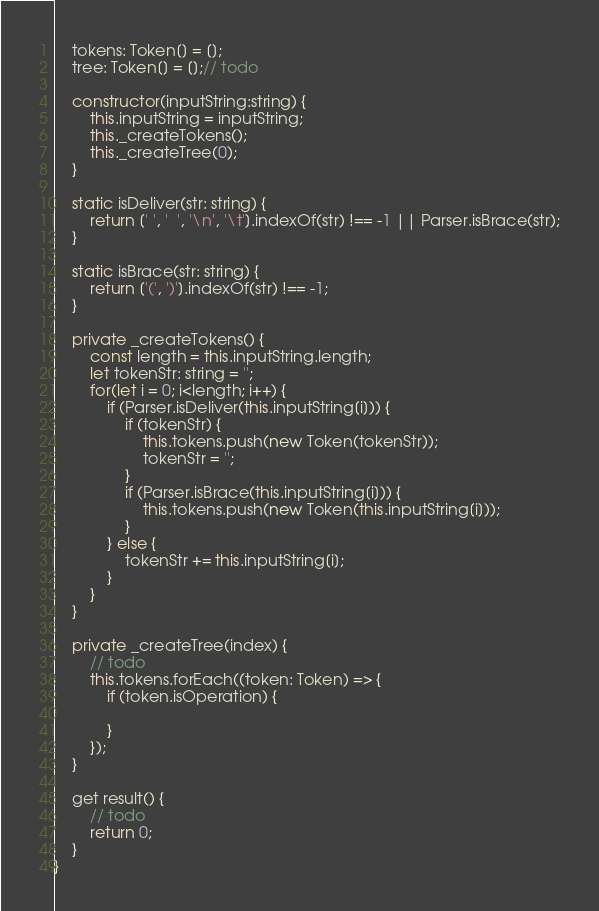<code> <loc_0><loc_0><loc_500><loc_500><_TypeScript_>    tokens: Token[] = [];
    tree: Token[] = [];// todo
    
    constructor(inputString:string) {
        this.inputString = inputString;
        this._createTokens();
        this._createTree(0);
    }

    static isDeliver(str: string) {
        return [' ', '  ', '\n', '\t'].indexOf(str) !== -1 || Parser.isBrace(str);
    }

    static isBrace(str: string) {
        return ['(', ')'].indexOf(str) !== -1;
    }

    private _createTokens() {
        const length = this.inputString.length;
        let tokenStr: string = '';
        for(let i = 0; i<length; i++) {
            if (Parser.isDeliver(this.inputString[i])) {
                if (tokenStr) {
                    this.tokens.push(new Token(tokenStr));
                    tokenStr = '';
                }
                if (Parser.isBrace(this.inputString[i])) {
                    this.tokens.push(new Token(this.inputString[i]));
                }
            } else {
                tokenStr += this.inputString[i];
            }
        }
    }
    
    private _createTree(index) {
        // todo
        this.tokens.forEach((token: Token) => {
            if (token.isOperation) {
                
            }
        });
    }

    get result() {
        // todo
        return 0;
    }
}
</code> 